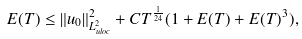<formula> <loc_0><loc_0><loc_500><loc_500>E ( T ) \leq \| u _ { 0 } \| _ { L ^ { 2 } _ { u l o c } } ^ { 2 } + C T ^ { \frac { 1 } { 2 4 } } ( 1 + E ( T ) + E ( T ) ^ { 3 } ) ,</formula> 